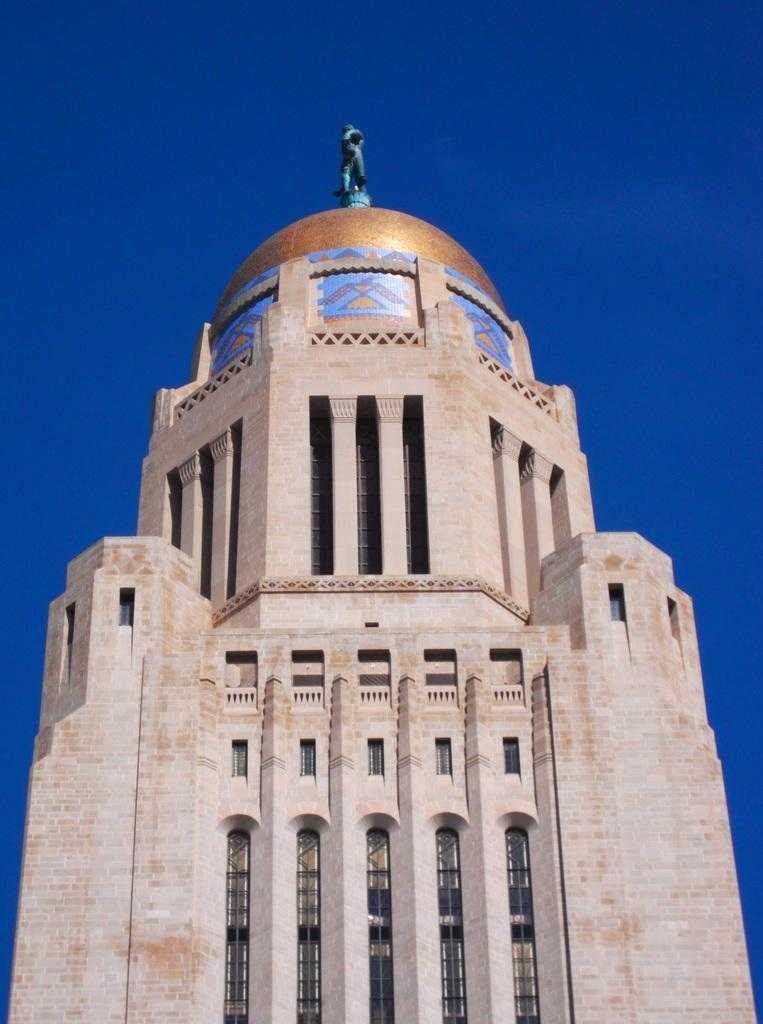What type of structure is visible in the image? There is a building in the image. What architectural features can be seen on the building? There are walls, pillars, and railings visible in the image. What type of objects can be seen in the image? There are glass objects in the image. What is visible in the background of the image? The sky is visible in the background of the image. What is located on top of the building? There is a statue on top of the building. What type of fingerprint can be seen on the glass objects in the image? There are no fingerprints visible on the glass objects in the image. What type of poison is being used by the judge in the image? There is no judge or poison present in the image. 